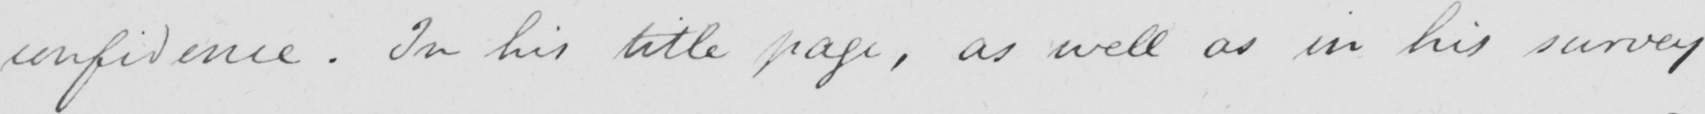Please provide the text content of this handwritten line. confidence . In his title page , as well as in his survey 